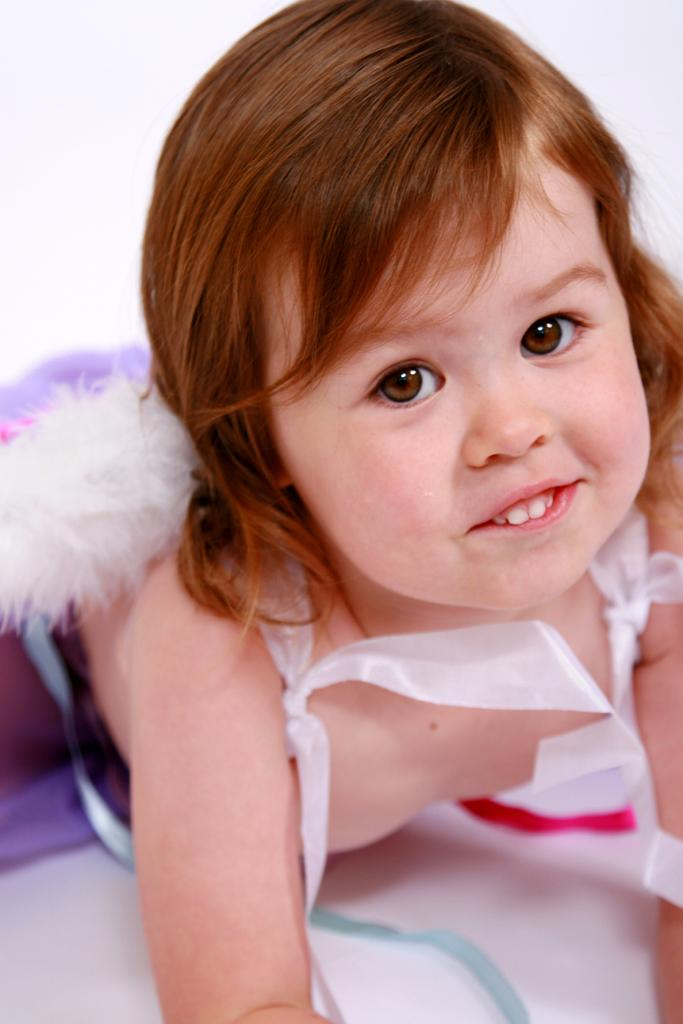What is the main subject of the image? The main subject of the image is a kid. What is the kid doing in the image? The kid is lying on a surface in the image. What type of station is visible in the image? There is no station present in the image; it features a kid lying on a surface. Can you tell me how many potatoes are being held by the goose in the image? There is no goose or potatoes present in the image. 